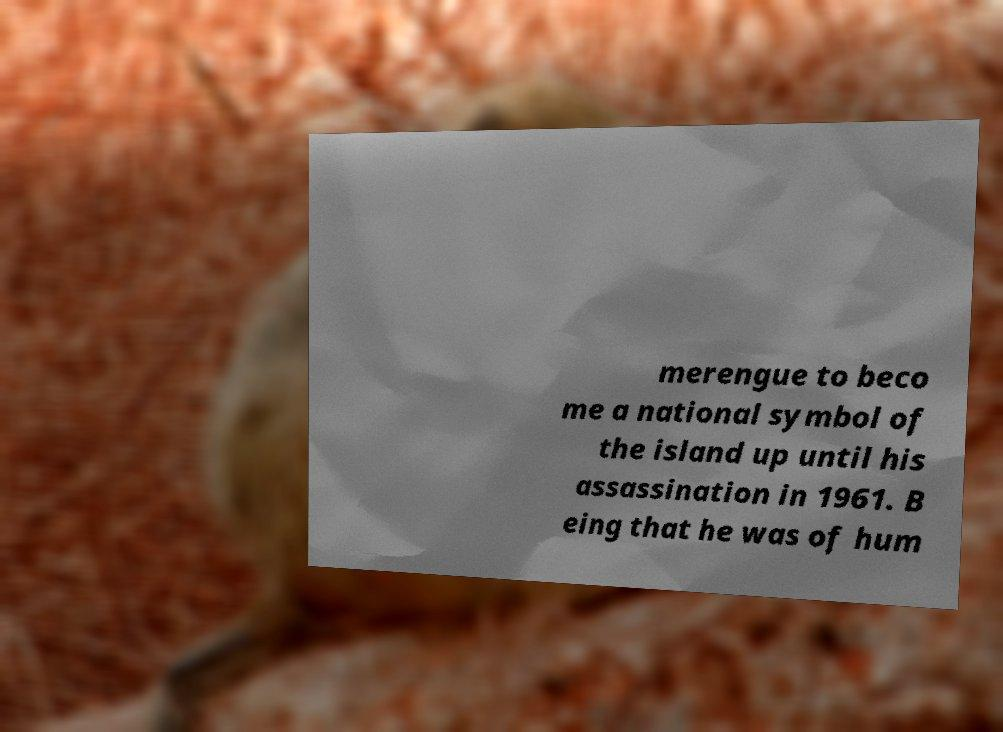There's text embedded in this image that I need extracted. Can you transcribe it verbatim? merengue to beco me a national symbol of the island up until his assassination in 1961. B eing that he was of hum 